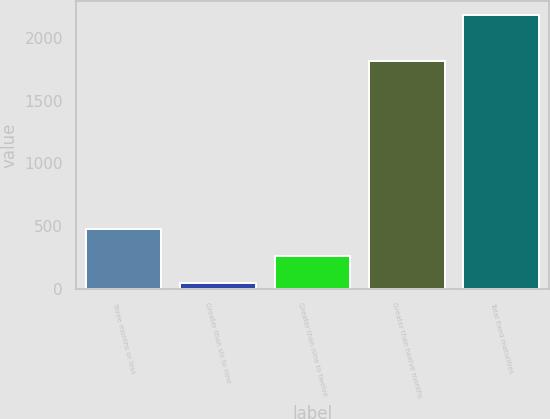Convert chart to OTSL. <chart><loc_0><loc_0><loc_500><loc_500><bar_chart><fcel>Three months or less<fcel>Greater than six to nine<fcel>Greater than nine to twelve<fcel>Greater than twelve months<fcel>Total fixed maturities<nl><fcel>473.66<fcel>46<fcel>259.83<fcel>1812.8<fcel>2184.3<nl></chart> 